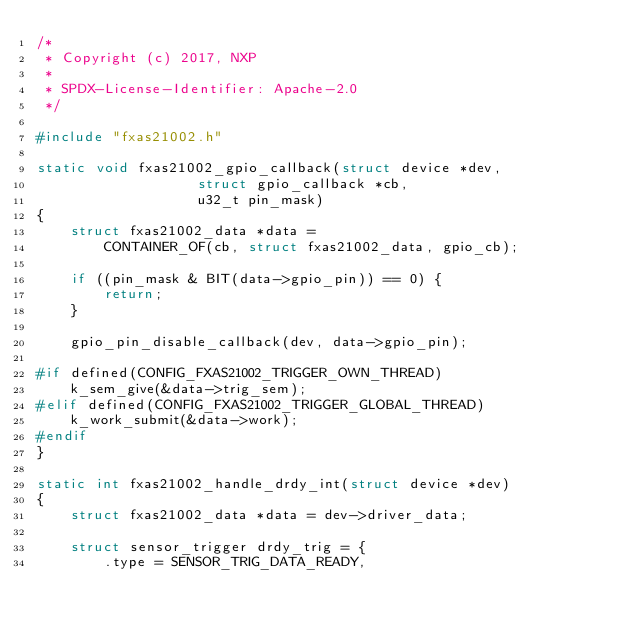Convert code to text. <code><loc_0><loc_0><loc_500><loc_500><_C_>/*
 * Copyright (c) 2017, NXP
 *
 * SPDX-License-Identifier: Apache-2.0
 */

#include "fxas21002.h"

static void fxas21002_gpio_callback(struct device *dev,
				   struct gpio_callback *cb,
				   u32_t pin_mask)
{
	struct fxas21002_data *data =
		CONTAINER_OF(cb, struct fxas21002_data, gpio_cb);

	if ((pin_mask & BIT(data->gpio_pin)) == 0) {
		return;
	}

	gpio_pin_disable_callback(dev, data->gpio_pin);

#if defined(CONFIG_FXAS21002_TRIGGER_OWN_THREAD)
	k_sem_give(&data->trig_sem);
#elif defined(CONFIG_FXAS21002_TRIGGER_GLOBAL_THREAD)
	k_work_submit(&data->work);
#endif
}

static int fxas21002_handle_drdy_int(struct device *dev)
{
	struct fxas21002_data *data = dev->driver_data;

	struct sensor_trigger drdy_trig = {
		.type = SENSOR_TRIG_DATA_READY,</code> 